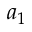Convert formula to latex. <formula><loc_0><loc_0><loc_500><loc_500>a _ { 1 }</formula> 